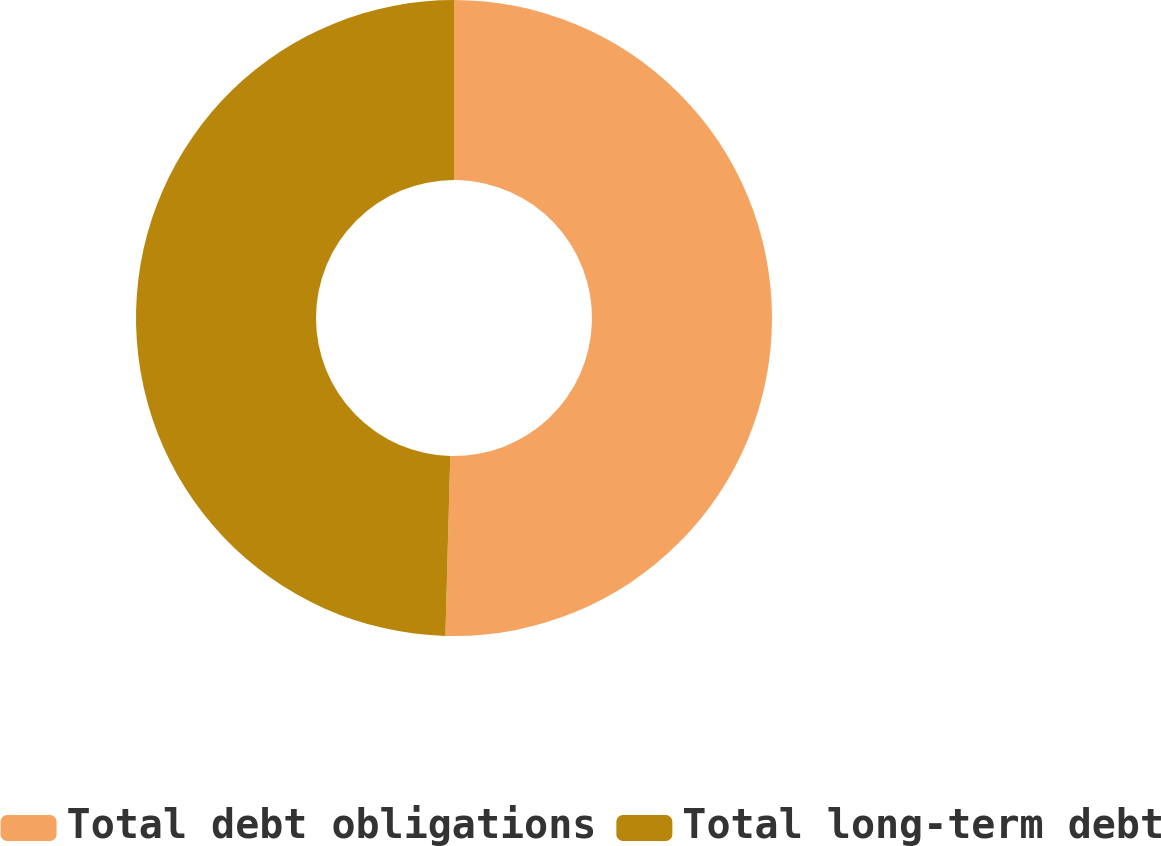<chart> <loc_0><loc_0><loc_500><loc_500><pie_chart><fcel>Total debt obligations<fcel>Total long-term debt<nl><fcel>50.43%<fcel>49.57%<nl></chart> 